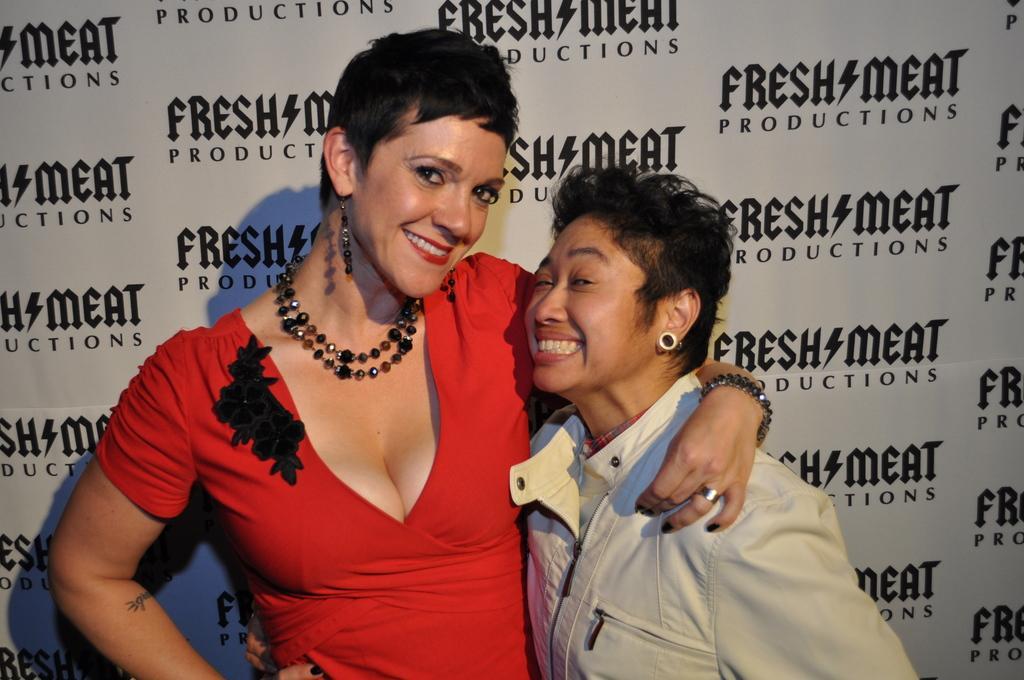Could you give a brief overview of what you see in this image? In this image there are two women, in the background there is a poster, on that poster some text is written. 